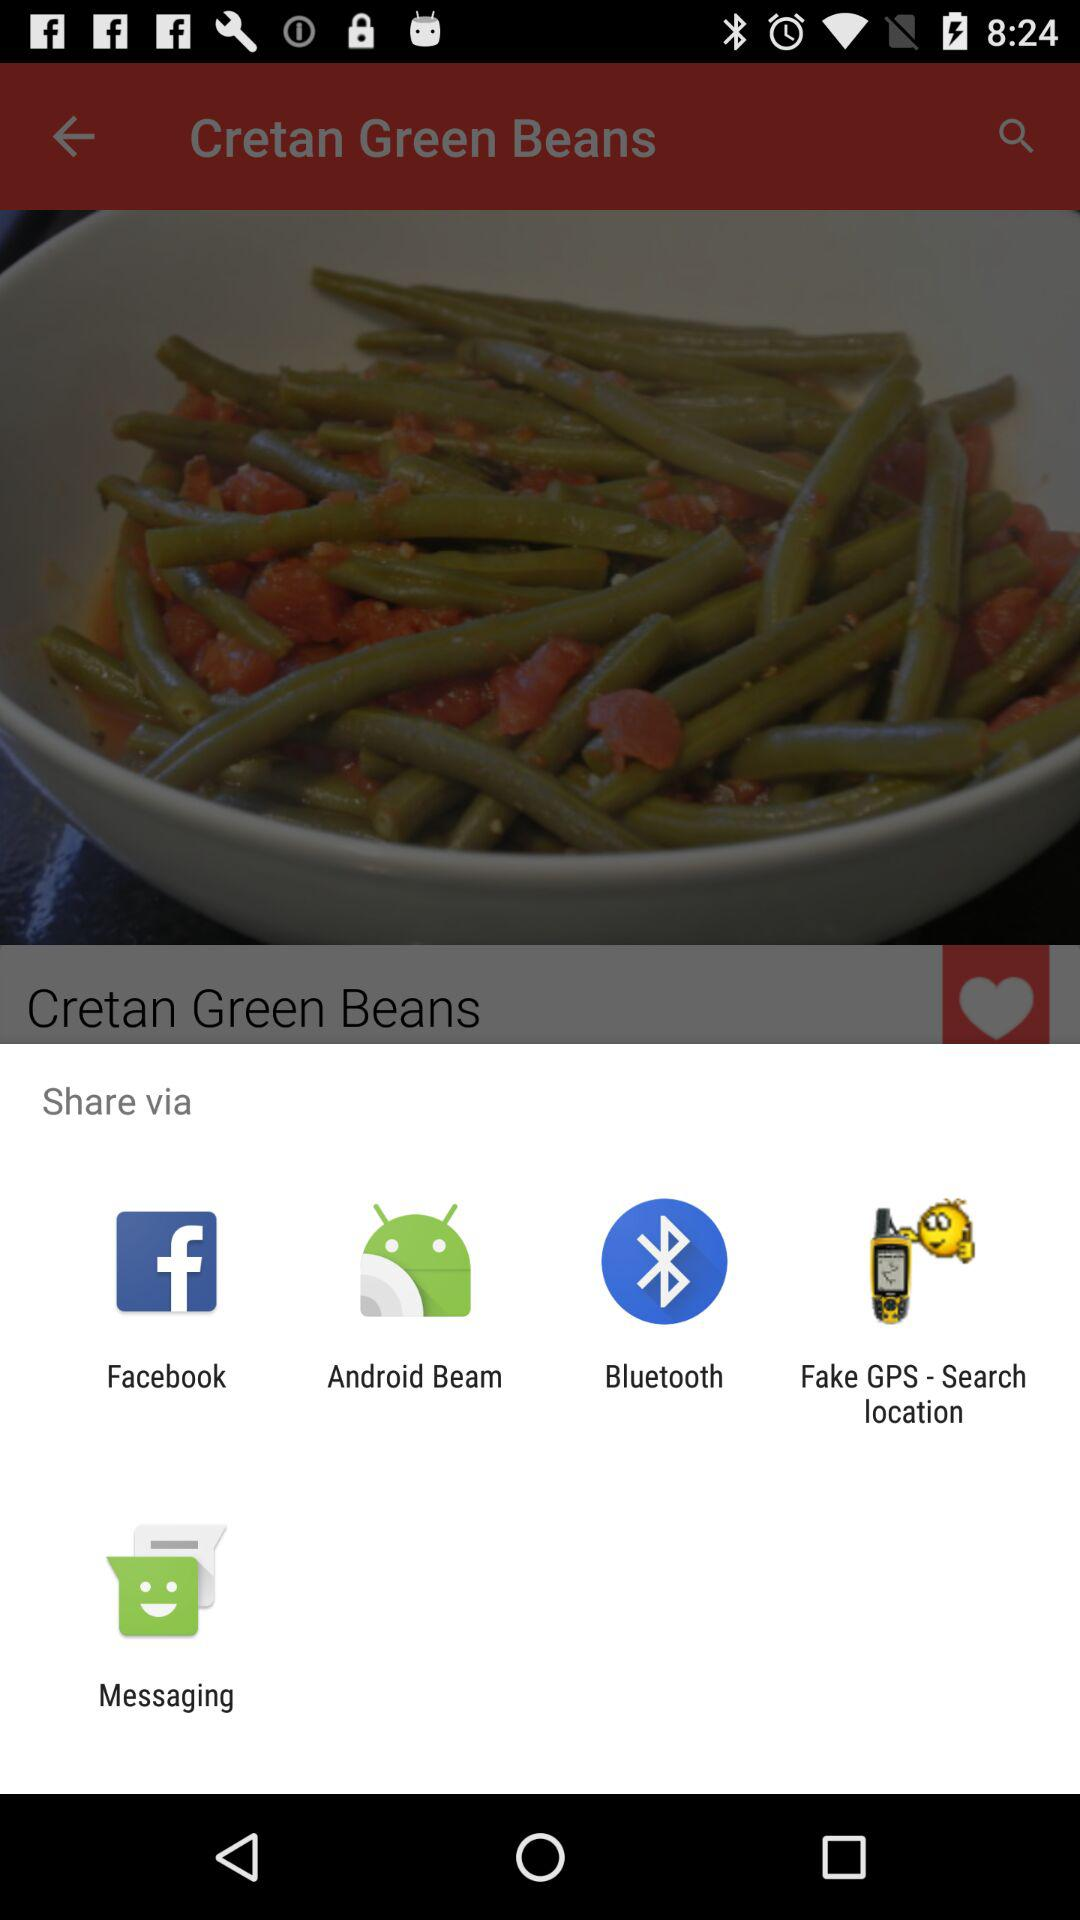What are the sharing options that I can use to share the content? The sharing options are "Facebook", "Android Beam", "Bluetooth", "Fake GPS - Search location" and "Messaging". 